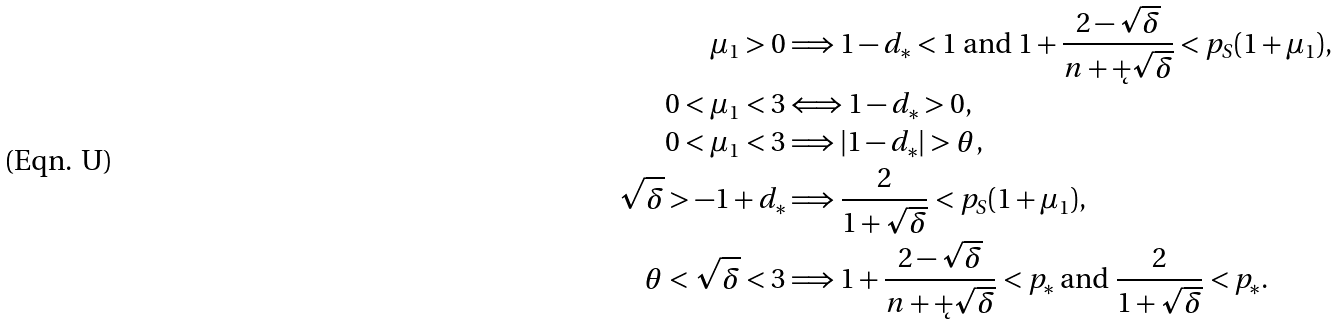<formula> <loc_0><loc_0><loc_500><loc_500>\mu _ { 1 } > 0 & \Longrightarrow \text {$1-d_{*} < 1$ and $1+\frac{2-\sqrt{\delta}}{n+\k+\sqrt{\delta}} < p_{S}(1+\mu_{1})$,} \\ 0 < \mu _ { 1 } < 3 & \Longleftrightarrow 1 - d _ { * } > 0 , \\ 0 < \mu _ { 1 } < 3 & \Longrightarrow | 1 - d _ { * } | > \theta , \\ \sqrt { \delta } > - 1 + d _ { * } & \Longrightarrow \frac { 2 } { 1 + \sqrt { \delta } } < p _ { S } ( 1 + \mu _ { 1 } ) , \\ \theta < \sqrt { \delta } < 3 & \Longrightarrow \text {$1+\frac{2-\sqrt{\delta}}{n+\k+\sqrt{\delta}}<p_{*}$ and $\frac{2}{1+\sqrt{\delta}} < p_{*}$} .</formula> 